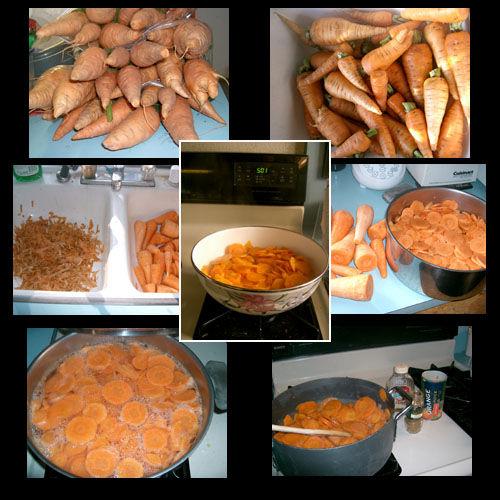Is this image a collage of foods?
Quick response, please. Yes. Are sweet potatoes classified as tubers?
Short answer required. Yes. Are all of the foods composed of the same veggie?
Write a very short answer. Yes. 